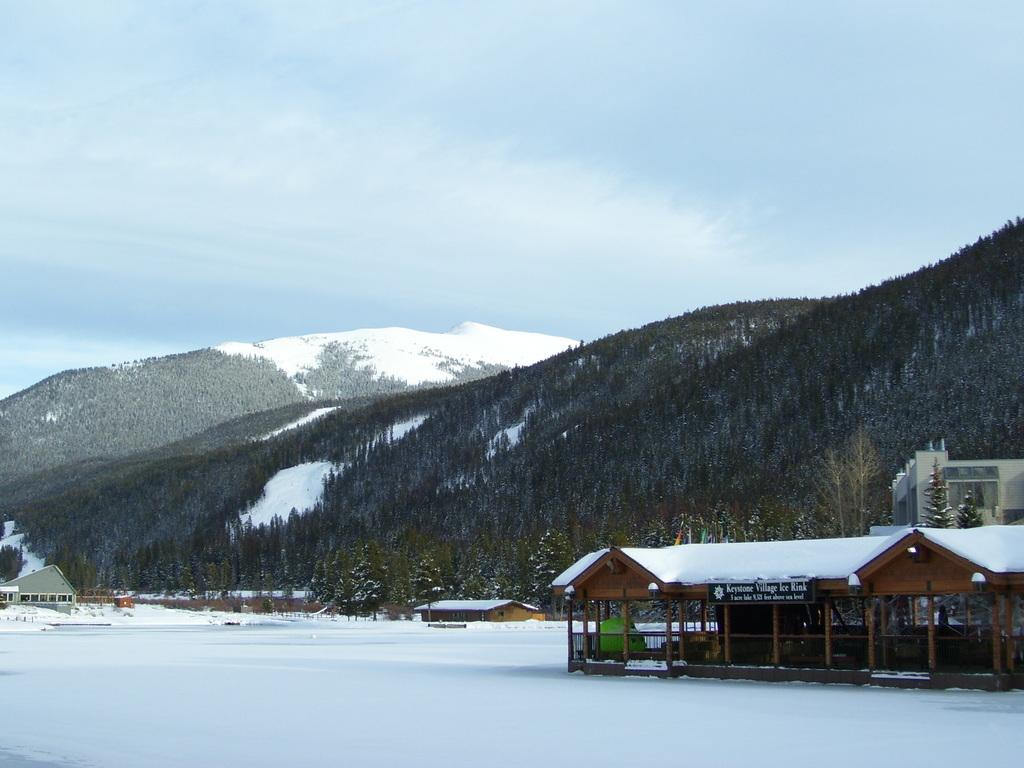What is the predominant color of the snow in the image? The snow in the image is white in color. Where is the house located in the image? The house is located on the right side of the image and is brown in color. What can be seen in the background of the image? There are mountains visible in the background of the image. What is the color of the sky in the image? The sky is blue in color and is visible at the top of the image. Can you hear the sound of a ray in the image? There is no sound or ray present in the image; it is a visual representation of snow, a house, mountains, and the sky. 